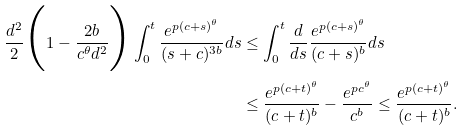Convert formula to latex. <formula><loc_0><loc_0><loc_500><loc_500>\frac { d ^ { 2 } } { 2 } \Big { ( } 1 - \frac { 2 b } { c ^ { \theta } d ^ { 2 } } \Big { ) } \int _ { 0 } ^ { t } \frac { e ^ { p ( c + s ) ^ { \theta } } } { ( s + c ) ^ { 3 b } } d s & \leq \int _ { 0 } ^ { t } \frac { d } { d s } \frac { e ^ { p ( c + s ) ^ { \theta } } } { ( c + s ) ^ { b } } d s \\ & \leq \frac { e ^ { p ( c + t ) ^ { \theta } } } { ( c + t ) ^ { b } } - \frac { e ^ { p c ^ { \theta } } } { c ^ { b } } \leq \frac { e ^ { p ( c + t ) ^ { \theta } } } { ( c + t ) ^ { b } } .</formula> 